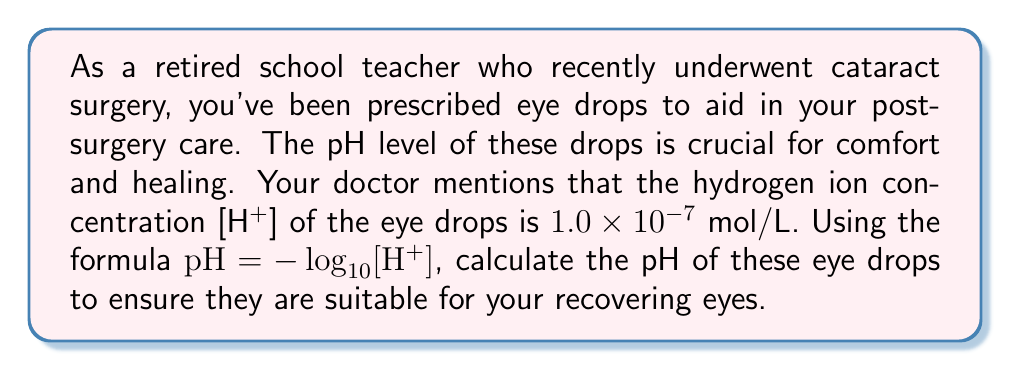Solve this math problem. Let's approach this step-by-step:

1) We are given the formula: $pH = -\log_{10}[H^+]$

2) We know that $[H^+] = 1.0 \times 10^{-7}$ mol/L

3) Let's substitute this into our formula:

   $pH = -\log_{10}(1.0 \times 10^{-7})$

4) Now, let's use the logarithm property: $\log_a(x \times 10^n) = \log_a(x) + n$

   $pH = -(\log_{10}(1.0) + (-7))$

5) We know that $\log_{10}(1.0) = 0$, so:

   $pH = -(0 + (-7))$

6) Simplify:

   $pH = -(-7) = 7$

Therefore, the pH of the eye drops is 7, which is neutral and generally safe for the eyes.
Answer: $pH = 7$ 